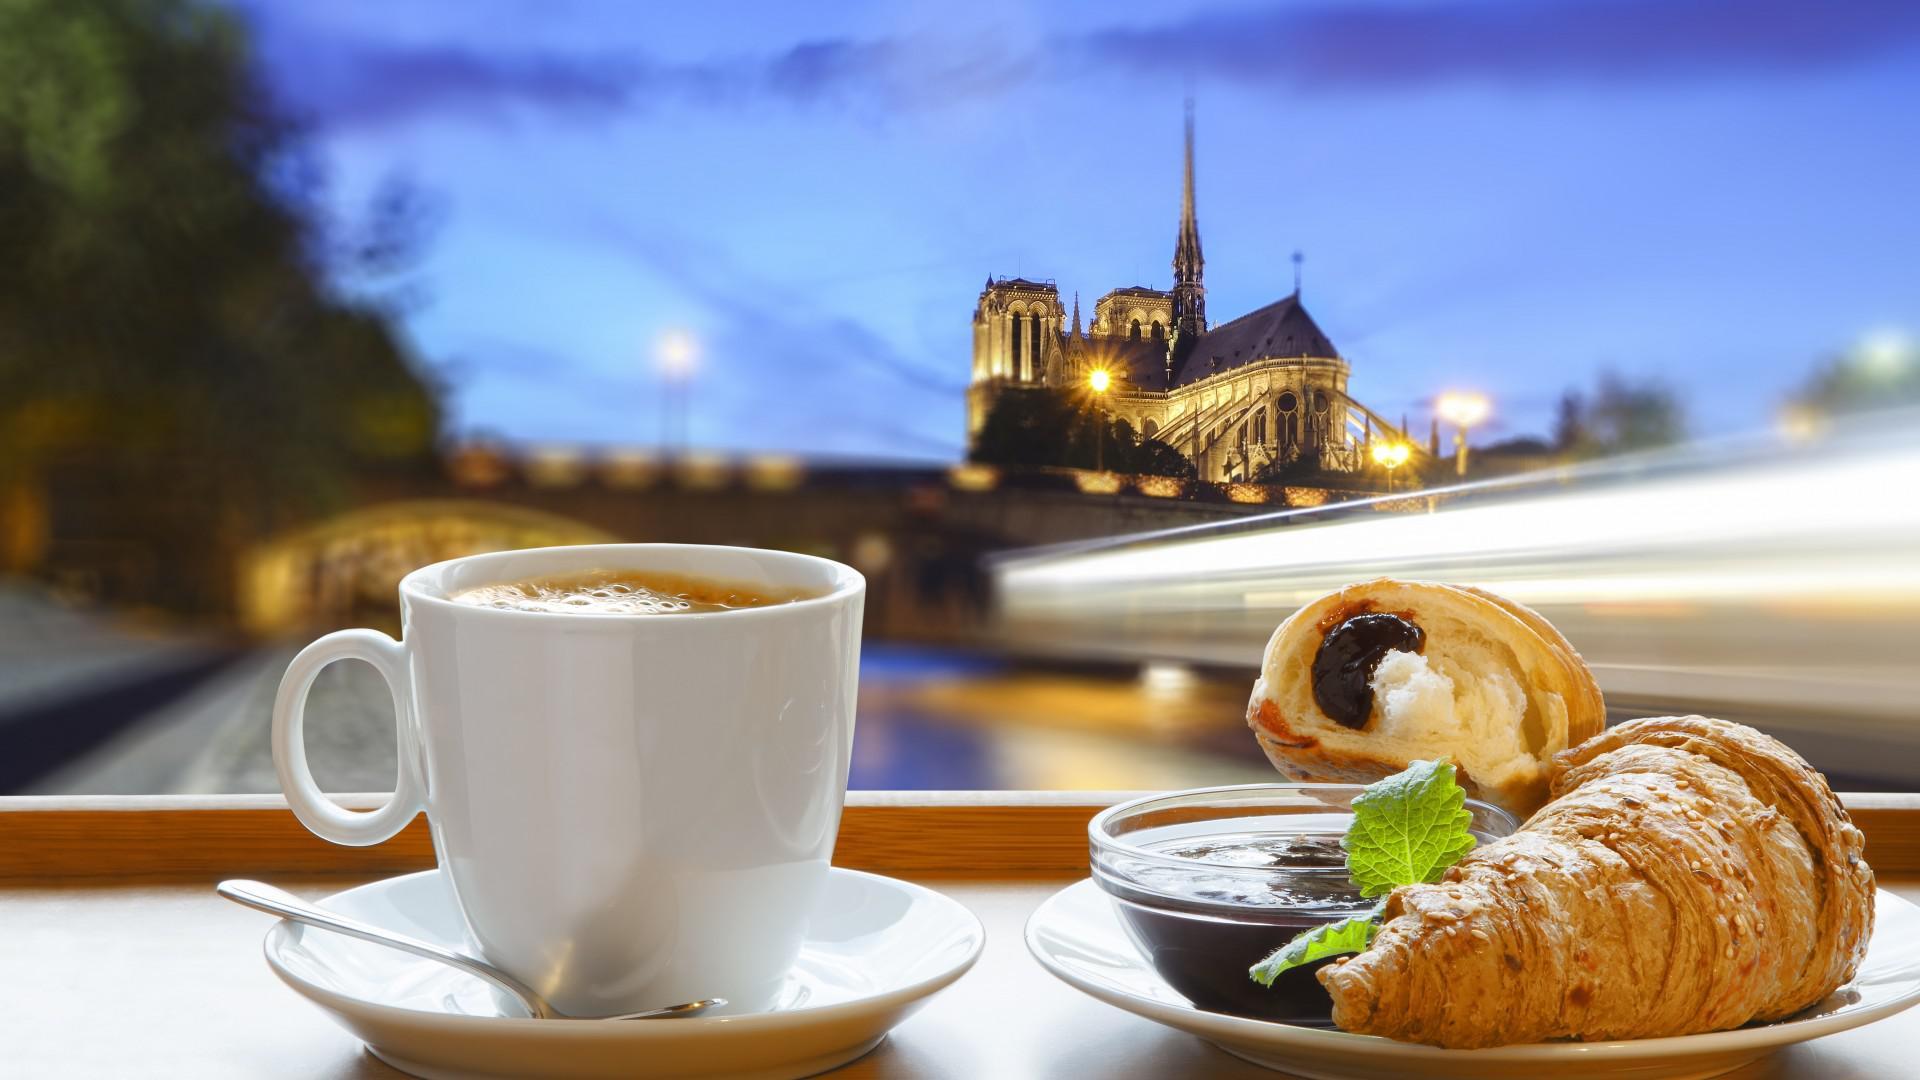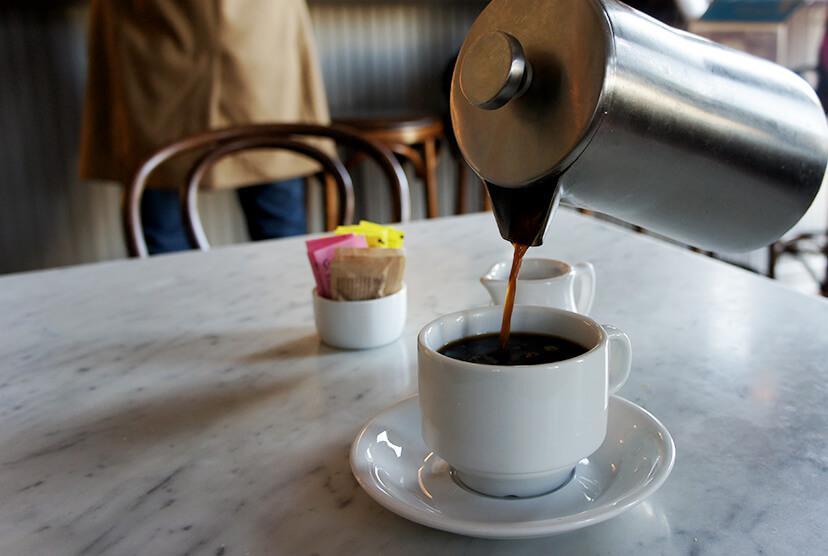The first image is the image on the left, the second image is the image on the right. Evaluate the accuracy of this statement regarding the images: "An image shows a container of fresh flowers and a tray containing two filled beverage cups.". Is it true? Answer yes or no. No. The first image is the image on the left, the second image is the image on the right. Considering the images on both sides, is "In one image, a bouquet of flowers is near two cups of coffee, while the second image shows one or more cups of coffee with matching saucers." valid? Answer yes or no. No. 